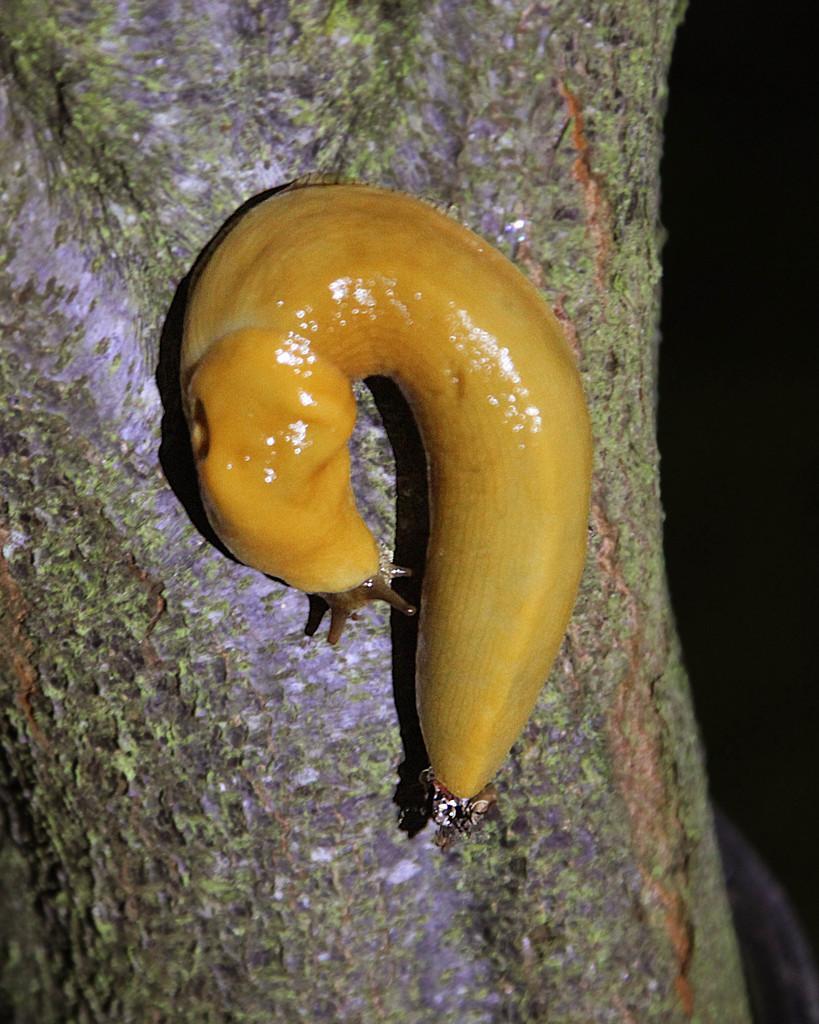Describe this image in one or two sentences. This image consists of a snail in brown color. It is on a tree. 